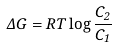<formula> <loc_0><loc_0><loc_500><loc_500>\Delta G = R T \log \frac { C _ { 2 } } { C _ { 1 } }</formula> 